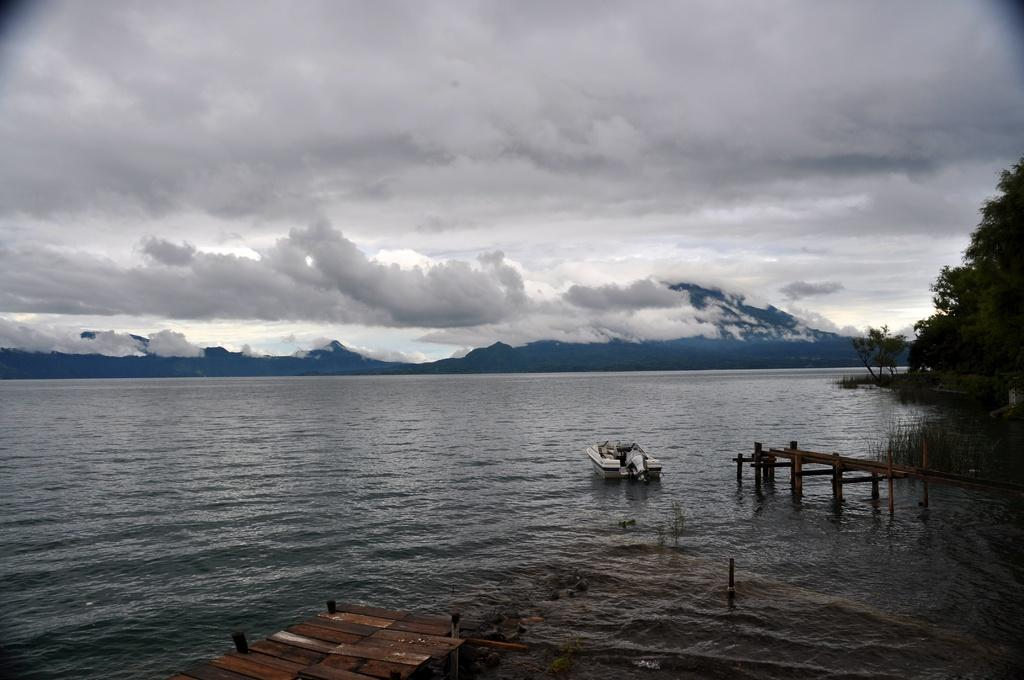What is the main subject of the image? The main subject of the image is a boat. Where is the boat located? The boat is on the water. What else can be seen in the image besides the boat? There are board bridges in the image. What is visible in the background of the image? There are trees in the background of the image. What is visible at the top of the image? There are clouds visible in the sky at the top of the image. What type of calculator is floating on the water next to the boat? There is no calculator present in the image; it only features a boat, board bridges, trees, and clouds. 